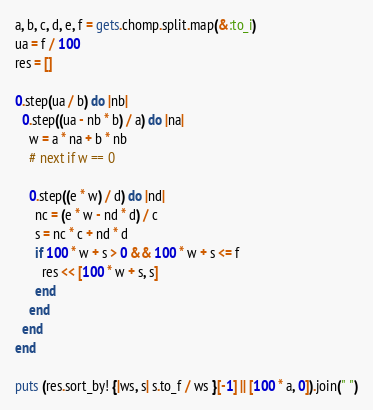<code> <loc_0><loc_0><loc_500><loc_500><_Ruby_>a, b, c, d, e, f = gets.chomp.split.map(&:to_i)
ua = f / 100
res = []

0.step(ua / b) do |nb|
  0.step((ua - nb * b) / a) do |na|
    w = a * na + b * nb
    # next if w == 0

    0.step((e * w) / d) do |nd|
      nc = (e * w - nd * d) / c
      s = nc * c + nd * d
      if 100 * w + s > 0 && 100 * w + s <= f
        res << [100 * w + s, s]
      end
    end
  end
end

puts (res.sort_by! {|ws, s| s.to_f / ws }[-1] || [100 * a, 0]).join(" ")</code> 